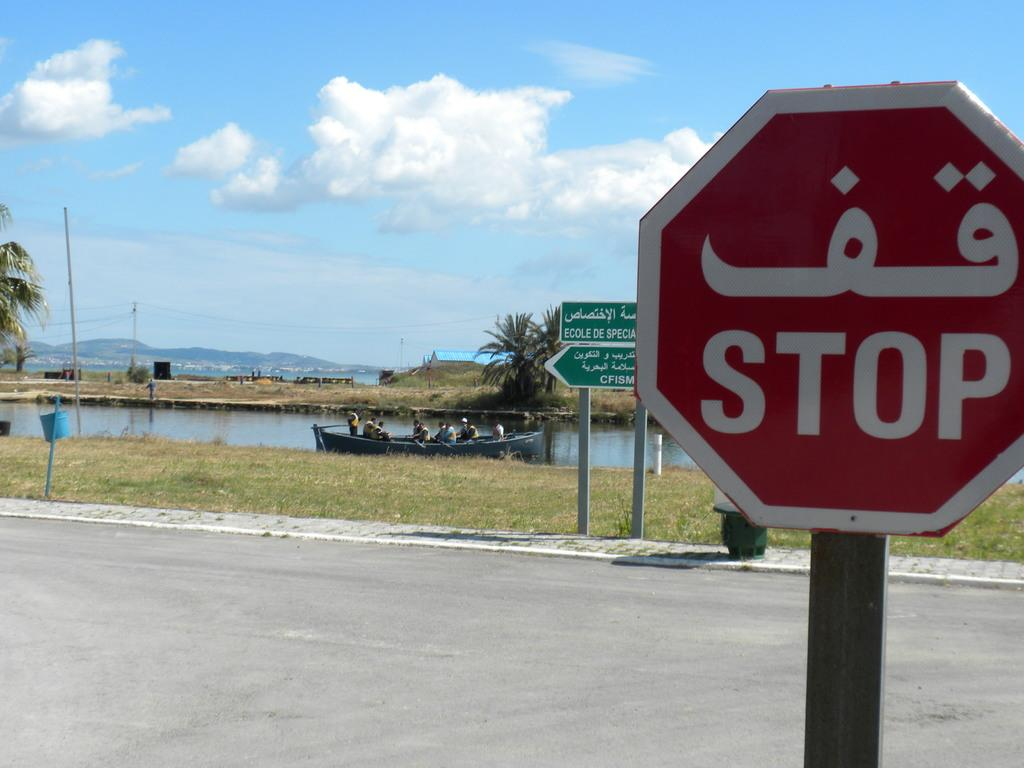<image>
Render a clear and concise summary of the photo. A stop sign displays the English language and also an Arabic language. 